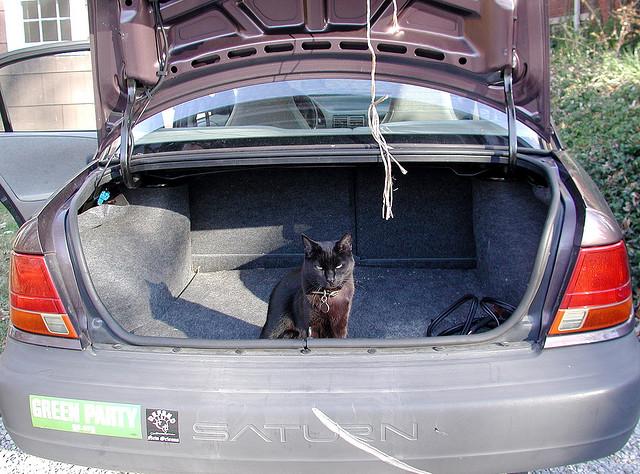Is the trunk open or closed?
Answer briefly. Open. What type of car is the cat in?
Short answer required. Saturn. Is the cat wearing a collar?
Be succinct. Yes. 